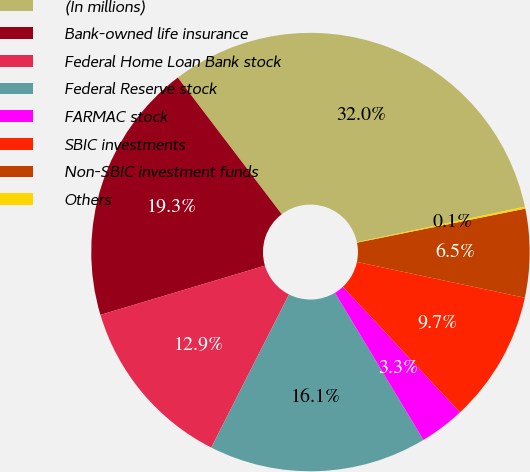Convert chart. <chart><loc_0><loc_0><loc_500><loc_500><pie_chart><fcel>(In millions)<fcel>Bank-owned life insurance<fcel>Federal Home Loan Bank stock<fcel>Federal Reserve stock<fcel>FARMAC stock<fcel>SBIC investments<fcel>Non-SBIC investment funds<fcel>Others<nl><fcel>32.03%<fcel>19.28%<fcel>12.9%<fcel>16.09%<fcel>3.33%<fcel>9.71%<fcel>6.52%<fcel>0.14%<nl></chart> 